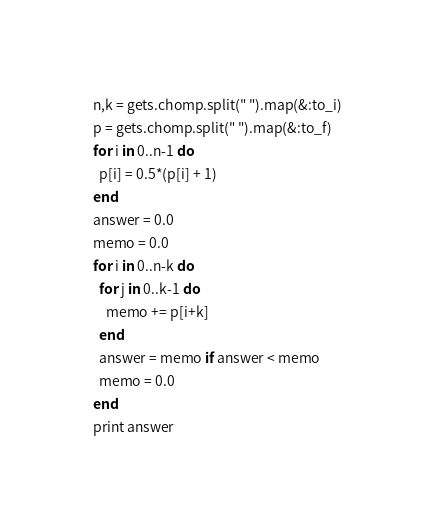Convert code to text. <code><loc_0><loc_0><loc_500><loc_500><_Ruby_>n,k = gets.chomp.split(" ").map(&:to_i)
p = gets.chomp.split(" ").map(&:to_f)
for i in 0..n-1 do
  p[i] = 0.5*(p[i] + 1)
end
answer = 0.0
memo = 0.0
for i in 0..n-k do
  for j in 0..k-1 do
    memo += p[i+k]
  end
  answer = memo if answer < memo
  memo = 0.0
end
print answer</code> 